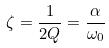<formula> <loc_0><loc_0><loc_500><loc_500>\zeta = \frac { 1 } { 2 Q } = \frac { \alpha } { \omega _ { 0 } }</formula> 